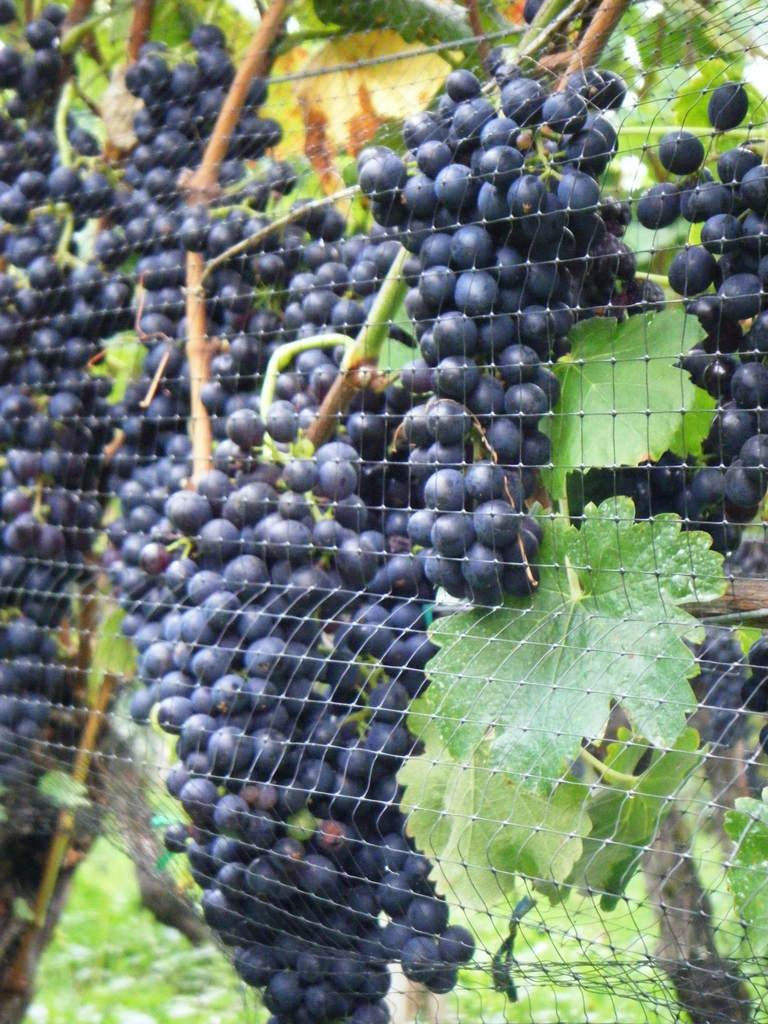What type of fence is visible in the image? There is a net fence in the image. What is hanging on the net fence? There are fruits on the net fence. What can be seen in addition to the fruits on the net fence? There are green leaves associated with the fruits. How many receipts can be seen on the net fence in the image? There are no receipts present on the net fence in the image. 